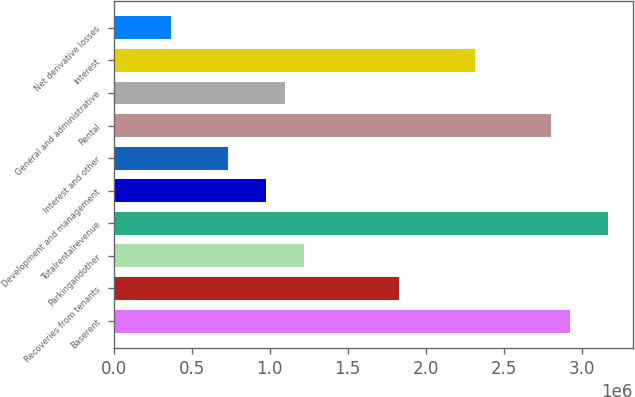Convert chart to OTSL. <chart><loc_0><loc_0><loc_500><loc_500><bar_chart><fcel>Baserent<fcel>Recoveries from tenants<fcel>Parkingandother<fcel>Totalrentalrevenue<fcel>Development and management<fcel>Interest and other<fcel>Rental<fcel>General and administrative<fcel>Interest<fcel>Net derivative losses<nl><fcel>2.92599e+06<fcel>1.82875e+06<fcel>1.21916e+06<fcel>3.16983e+06<fcel>975332<fcel>731499<fcel>2.80408e+06<fcel>1.09725e+06<fcel>2.31641e+06<fcel>365750<nl></chart> 